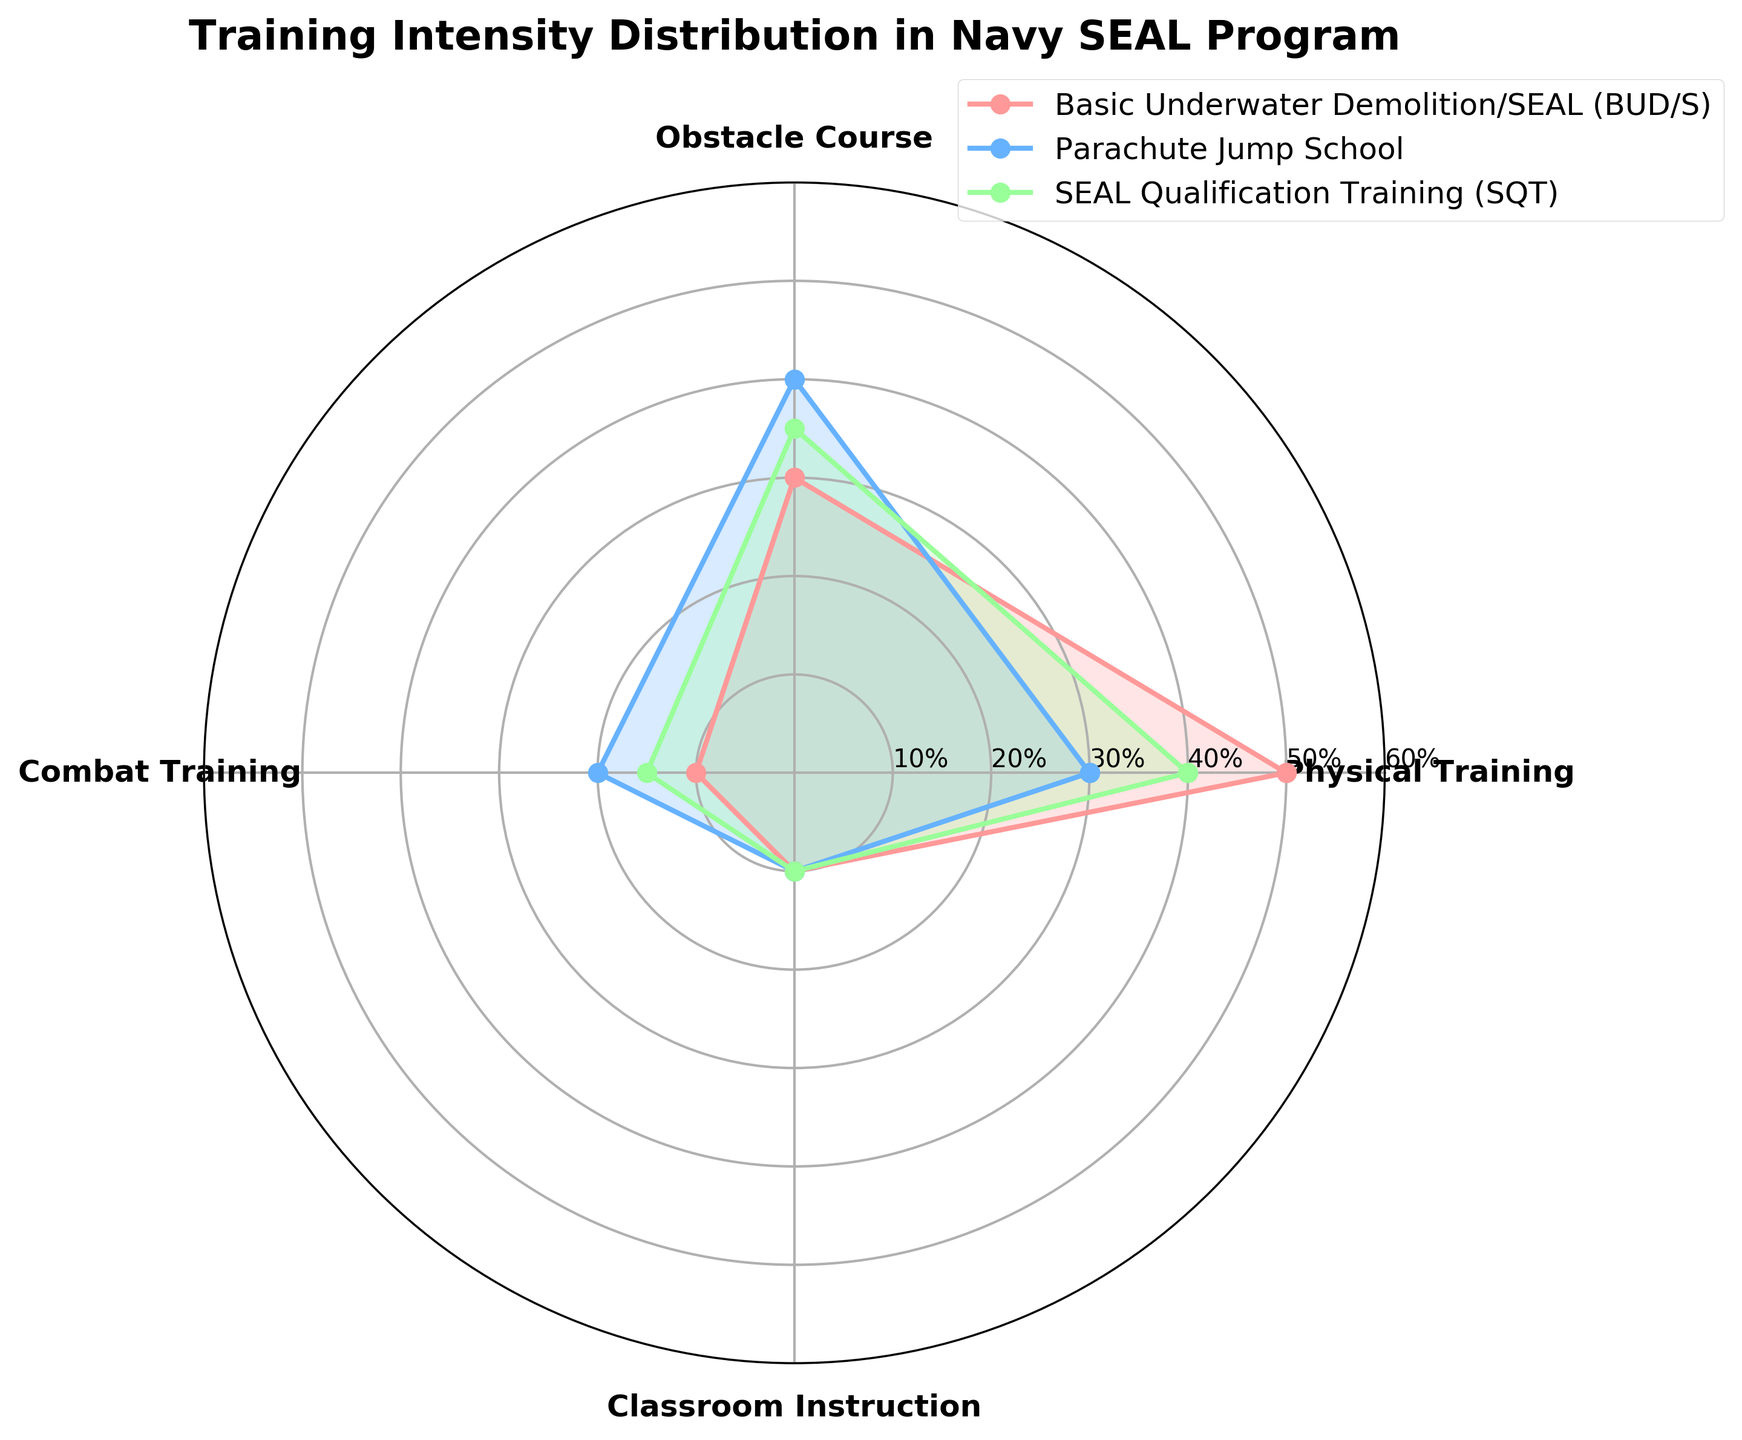What's the title of the plot? The title of the plot is written at the top of the figure.
Answer: Training Intensity Distribution in Navy SEAL Program What are the four categories measured in the plot? The categories are listed around the plot at each primary angle.
Answer: Physical Training, Obstacle Course, Combat Training, Classroom Instruction Which stage has the highest percentage of Physical Training? The stage with the longest arm in the "Physical Training" direction shows the highest percentage. This occurs in the Basic Underwater Demolition/SEAL (BUD/S) stage.
Answer: Basic Underwater Demolition/SEAL (BUD/S) Which stage has the lowest percentage in Classroom Instruction? Look at the lengths of the arms corresponding to "Classroom Instruction" and identify the shortest one among the stages. Parachute Jump School, SEAL Qualification Training (SQT), and Basic Underwater Demolition/SEAL (BUD/S) stages all have 10% for Classroom Instruction, but the lowest is still 10%.
Answer: All stages in the plot have 10% Compare the Obstacle Course percentages between Basic Underwater Demolition/SEAL (BUD/S) and Parachute Jump School. Which stage has a higher percentage? Identify the arms corresponding to "Obstacle Course" and measure their lengths. Parachute Jump School has 40%, whereas Basic Underwater Demolition/SEAL (BUD/S) has 30%.
Answer: Parachute Jump School What is the total intensity percentage for SEAL Qualification Training (SQT)? Add the percentages for Physical Training, Obstacle Course, Combat Training, and Classroom Instruction for SEAL Qualification Training (SQT). The values are 40% + 35% + 15% + 10%.
Answer: 100% During which stage is Combat Training emphasized the most? Look at the lengths of the arms corresponding to "Combat Training" and identify the longest one among the stages. The largest value is in the Parachute Jump School stage with 20%.
Answer: Parachute Jump School What is the average percentage value for Obstacle Course across the three stages shown? Add the Obstacle Course percentages for the three stages and divide by the number of stages: (30% + 40% + 35%) / 3.
Answer: 35% Between Basic Underwater Demolition/SEAL (BUD/S) and SEAL Qualification Training (SQT), which stage has a more balanced distribution of training intensities? Look for stages where the percentages are closer to each other, indicating a more balanced distribution. Basic Underwater Demolition/SEAL (BUD/S) has a wider range (50%-10%), while SEAL Qualification Training (SQT) ranges from 40% to 10%. The latter stage seems to have a more even spread.
Answer: SEAL Qualification Training (SQT) Which stage shows an equal effort in Physical Training and Combat Training? Look for the stage where the values for Physical Training and Combat Training are the same. No stage has equal percentages for these two categories.
Answer: None 